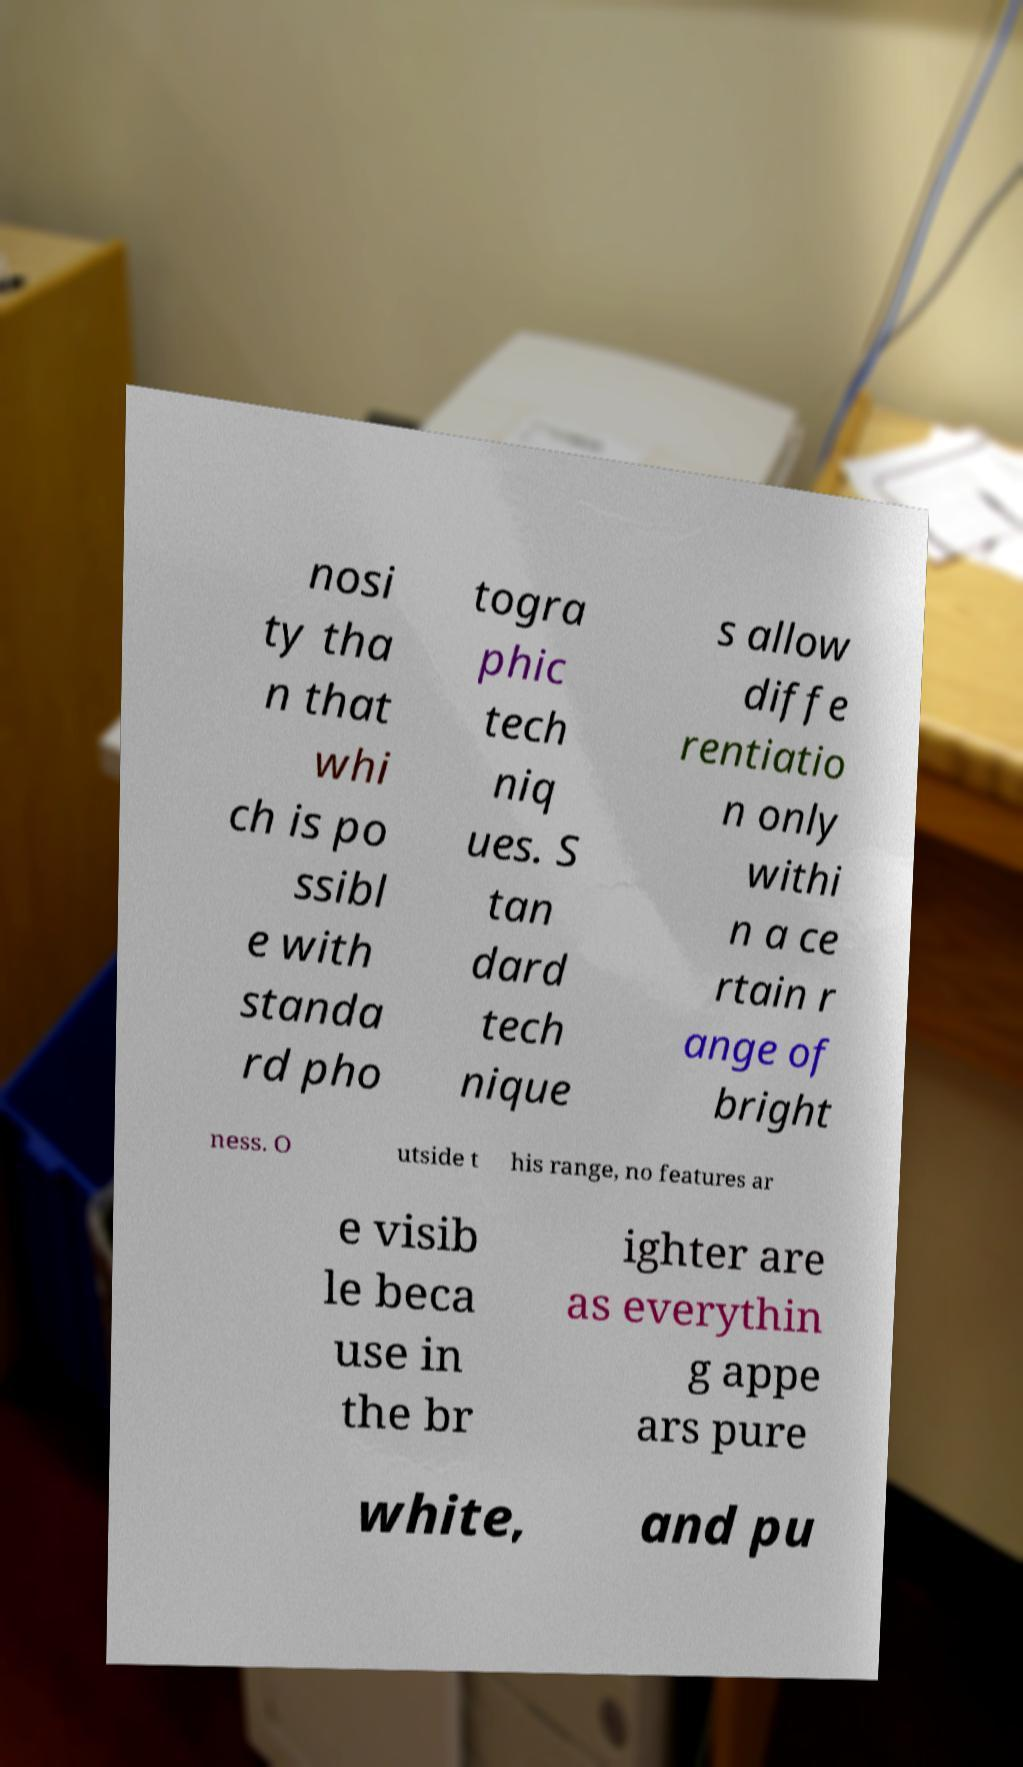I need the written content from this picture converted into text. Can you do that? nosi ty tha n that whi ch is po ssibl e with standa rd pho togra phic tech niq ues. S tan dard tech nique s allow diffe rentiatio n only withi n a ce rtain r ange of bright ness. O utside t his range, no features ar e visib le beca use in the br ighter are as everythin g appe ars pure white, and pu 